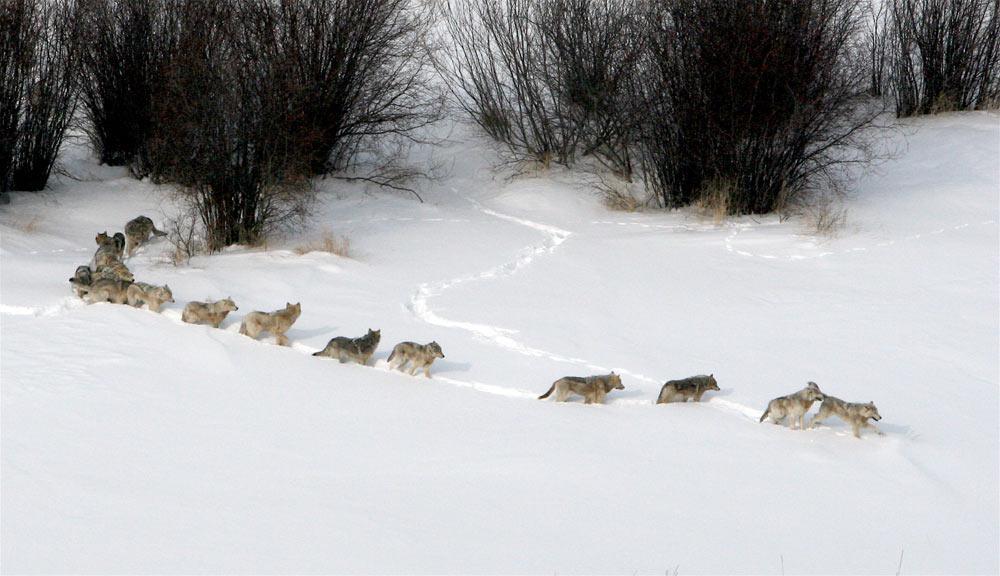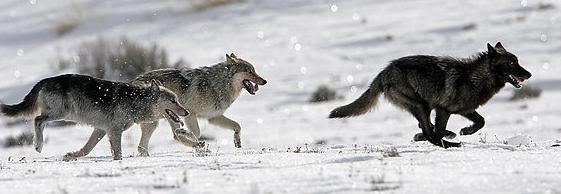The first image is the image on the left, the second image is the image on the right. Evaluate the accuracy of this statement regarding the images: "An image shows exactly three wolves, including one black one, running in a rightward direction.". Is it true? Answer yes or no. Yes. The first image is the image on the left, the second image is the image on the right. Assess this claim about the two images: "There is at least one wolf that is completely black.". Correct or not? Answer yes or no. Yes. 